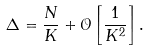Convert formula to latex. <formula><loc_0><loc_0><loc_500><loc_500>\Delta = \frac { N } { K } + \mathcal { O } \left [ \frac { 1 } { K ^ { 2 } } \right ] .</formula> 